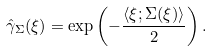Convert formula to latex. <formula><loc_0><loc_0><loc_500><loc_500>\hat { \gamma } _ { \Sigma } ( \xi ) = \exp \left ( - \frac { \langle \xi ; \Sigma ( \xi ) \rangle } { 2 } \right ) .</formula> 